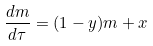<formula> <loc_0><loc_0><loc_500><loc_500>\frac { d m } { d \tau } = ( 1 - y ) m + x</formula> 